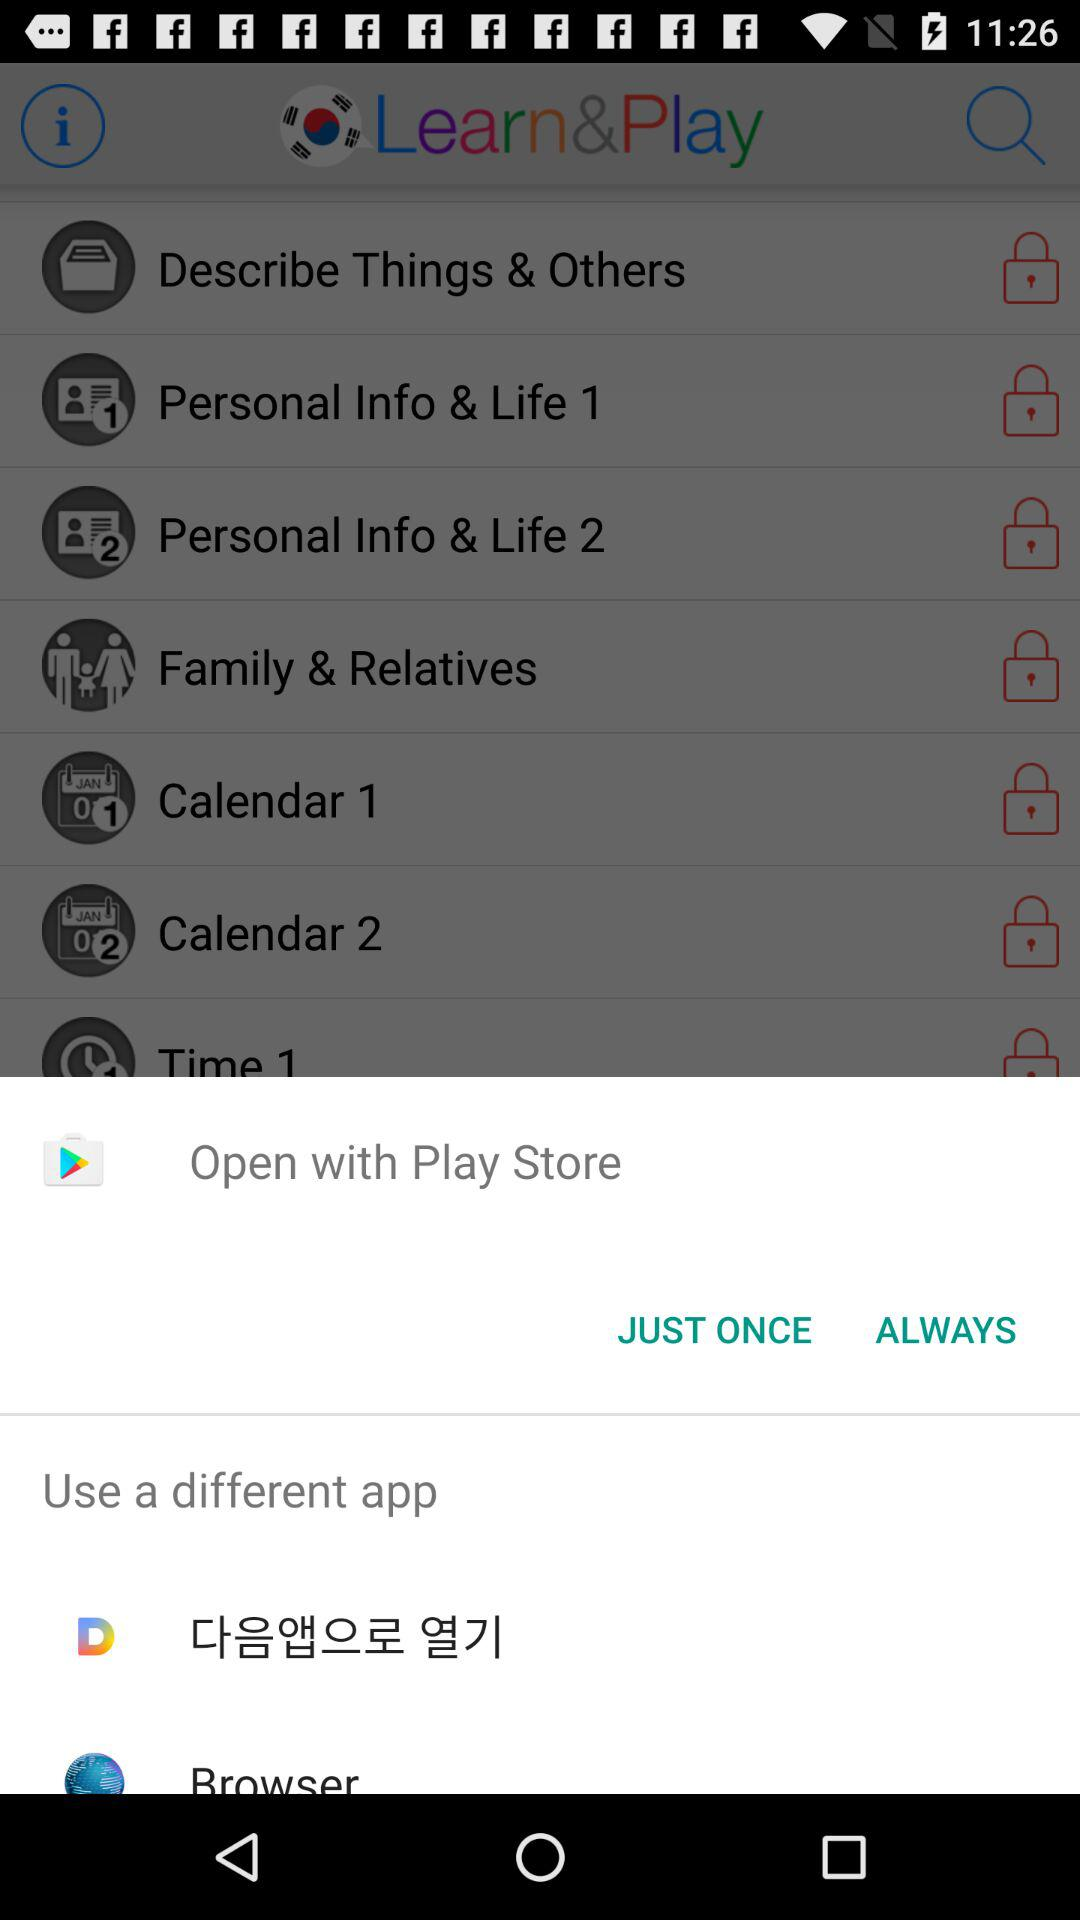Can we open this in a different app?
When the provided information is insufficient, respond with <no answer>. <no answer> 